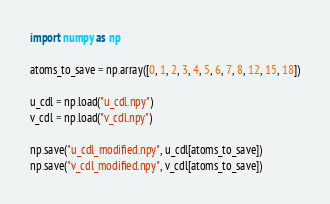Convert code to text. <code><loc_0><loc_0><loc_500><loc_500><_Python_>import numpy as np

atoms_to_save = np.array([0, 1, 2, 3, 4, 5, 6, 7, 8, 12, 15, 18])

u_cdl = np.load("u_cdl.npy")
v_cdl = np.load("v_cdl.npy")

np.save("u_cdl_modified.npy", u_cdl[atoms_to_save])
np.save("v_cdl_modified.npy", v_cdl[atoms_to_save])
</code> 